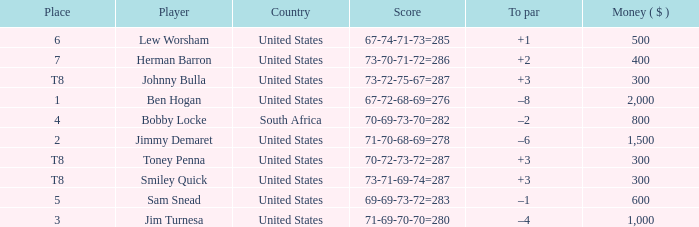What is the To par of the Player with a Score of 73-70-71-72=286? 2.0. 